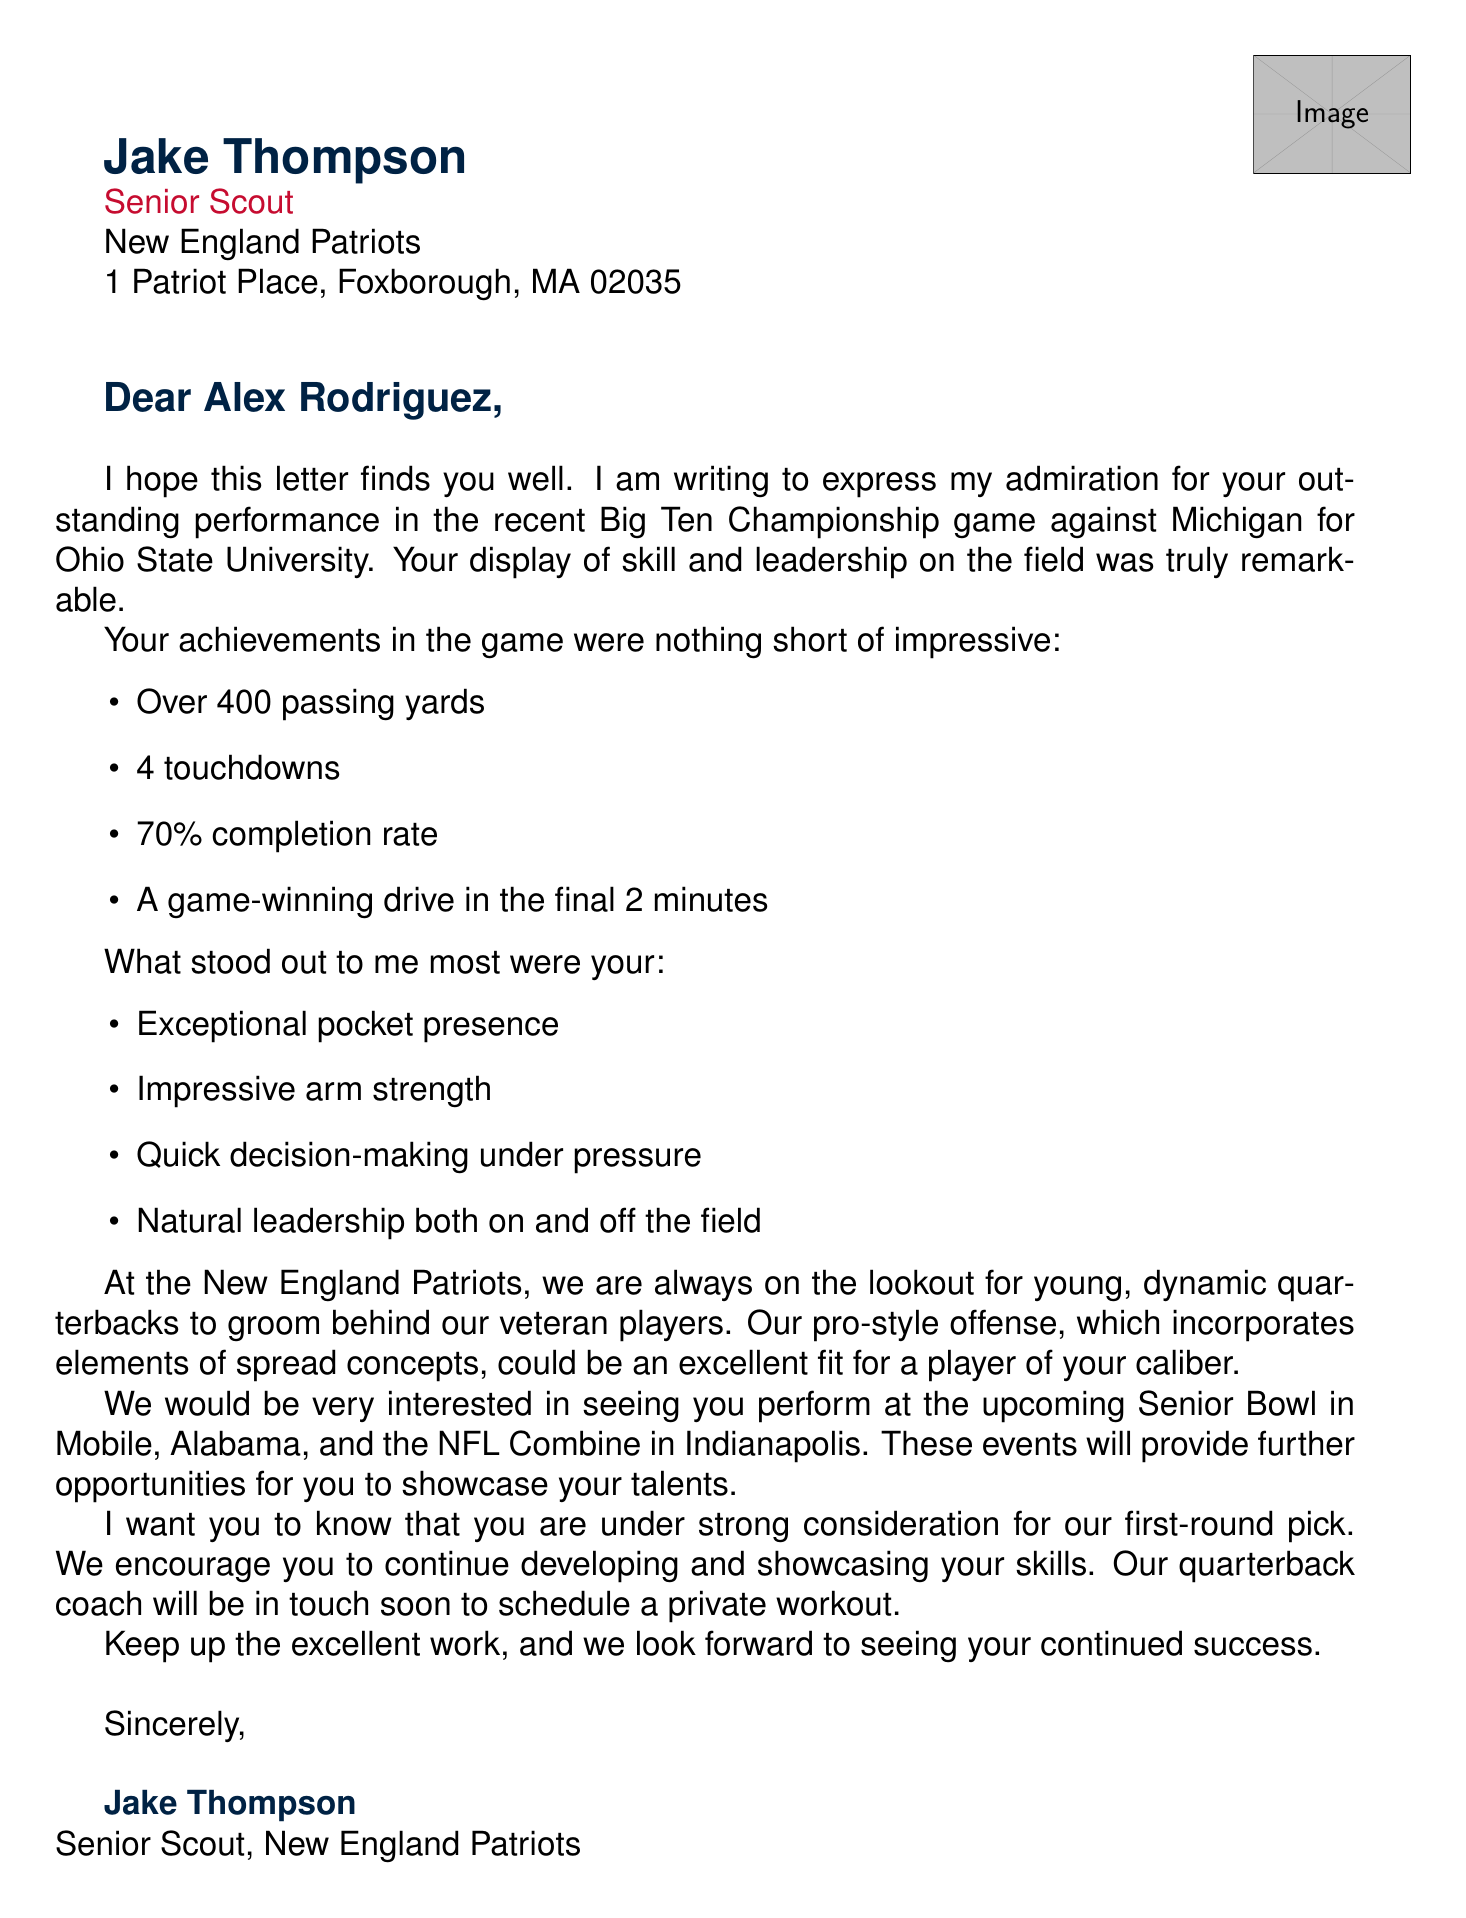who is the sender of the letter? The sender of the letter is identified in the document header as Jake Thompson.
Answer: Jake Thompson what is the position of the sender? The letter specifies the sender's title as Senior Scout.
Answer: Senior Scout what college does the player attend? The document states the player's college as Ohio State University.
Answer: Ohio State University how many touchdowns did the player throw in the recent game? The player is reported to have thrown 4 touchdowns in the game.
Answer: 4 touchdowns what is the player's completion rate in the recent game? The document mentions the player's completion rate as 70%.
Answer: 70% which game is highlighted in the letter? The document highlights the Big Ten Championship against Michigan.
Answer: Big Ten Championship against Michigan what qualities did the scout emphasize about the player? The scout emphasized qualities like pocket presence, arm strength, decision-making, and leadership.
Answer: Pocket presence, Arm strength, Decision-making, Leadership what events does the scout mention for showcasing talents? The scout mentions the Senior Bowl and NFL Combine as opportunities to showcase talents.
Answer: Senior Bowl, NFL Combine what is the expressed interest from the scout regarding the player? The scout expresses strong consideration for the player's potential as a first-round pick.
Answer: Strong consideration for our first-round pick 